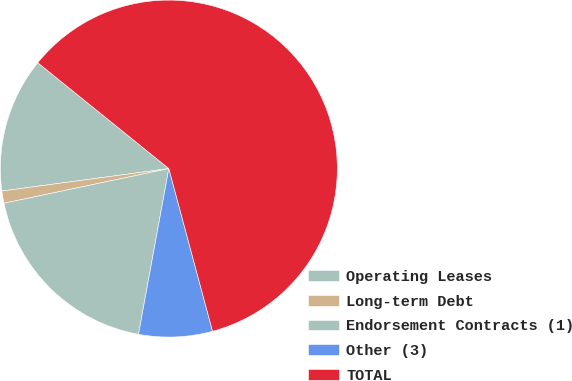Convert chart. <chart><loc_0><loc_0><loc_500><loc_500><pie_chart><fcel>Operating Leases<fcel>Long-term Debt<fcel>Endorsement Contracts (1)<fcel>Other (3)<fcel>TOTAL<nl><fcel>12.94%<fcel>1.17%<fcel>18.82%<fcel>7.06%<fcel>60.01%<nl></chart> 